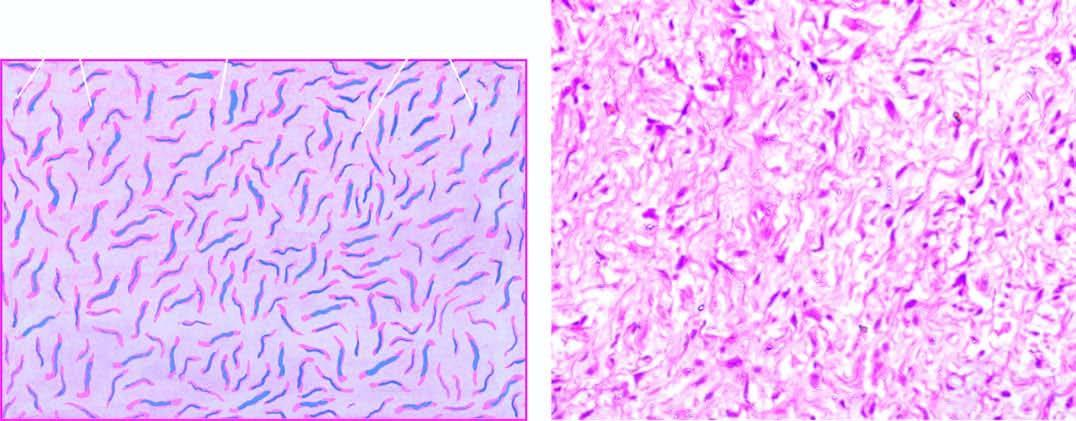how does neurofibroma show interlacing bundles of spindle-shaped cells?
Answer the question using a single word or phrase. By mucoid matrix 